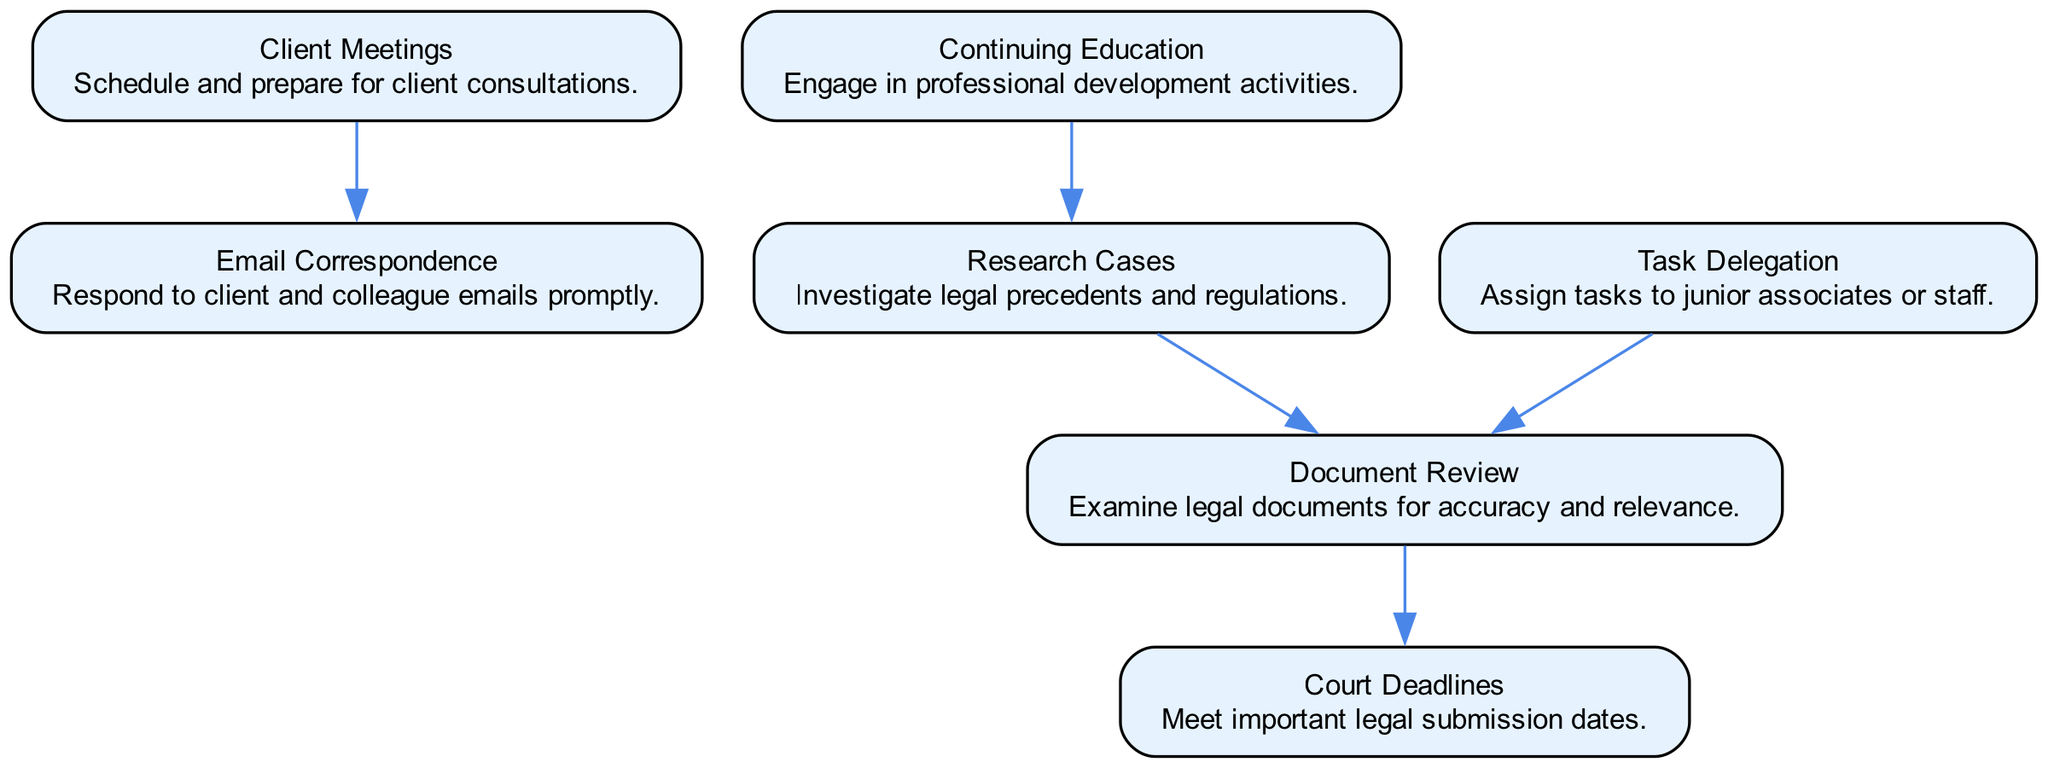What is the total number of nodes in the diagram? The diagram contains a total of seven nodes related to task prioritization, which represent different daily activities.
Answer: 7 Which node is directly connected to "Client Meetings"? The edge from "Client Meetings" points directly to "Email Correspondence", indicating that emails should be dealt with following client meetings.
Answer: Email Correspondence What is the relationship between "Document Review" and "Court Deadlines"? There is a directed edge from "Document Review" to "Court Deadlines", meaning that completing document review is necessary to meet court deadlines.
Answer: Document Review -> Court Deadlines How many edges are present in the graph? By counting the connections between the nodes, we find that there are five directed edges present in total.
Answer: 5 What activity precedes "Task Delegation"? "Task Delegation" is connected to "Document Review", showing that delegating tasks is dependent on reviewing documents first.
Answer: Document Review Which node is a prerequisite for "Document Review"? The directed edges indicate that both "Research Cases" and "Task Delegation" lead to "Document Review", indicating they are prerequisites.
Answer: Research Cases, Task Delegation In what direction does "Continuing Education" influence the diagram? "Continuing Education" is connected to "Research Cases"; it feeds into that activity, suggesting it enhances knowledge for case research.
Answer: Research Cases What can be inferred about the connection from "Research Cases" to other tasks? "Research Cases" is integral to the workflow, influencing "Document Review", indicating its importance in understanding legal contexts.
Answer: Document Review Which node has no outgoing edges? "Client Meetings" can be identified as having no outgoing edges, meaning no tasks depend directly on its completion in this graph.
Answer: Client Meetings 